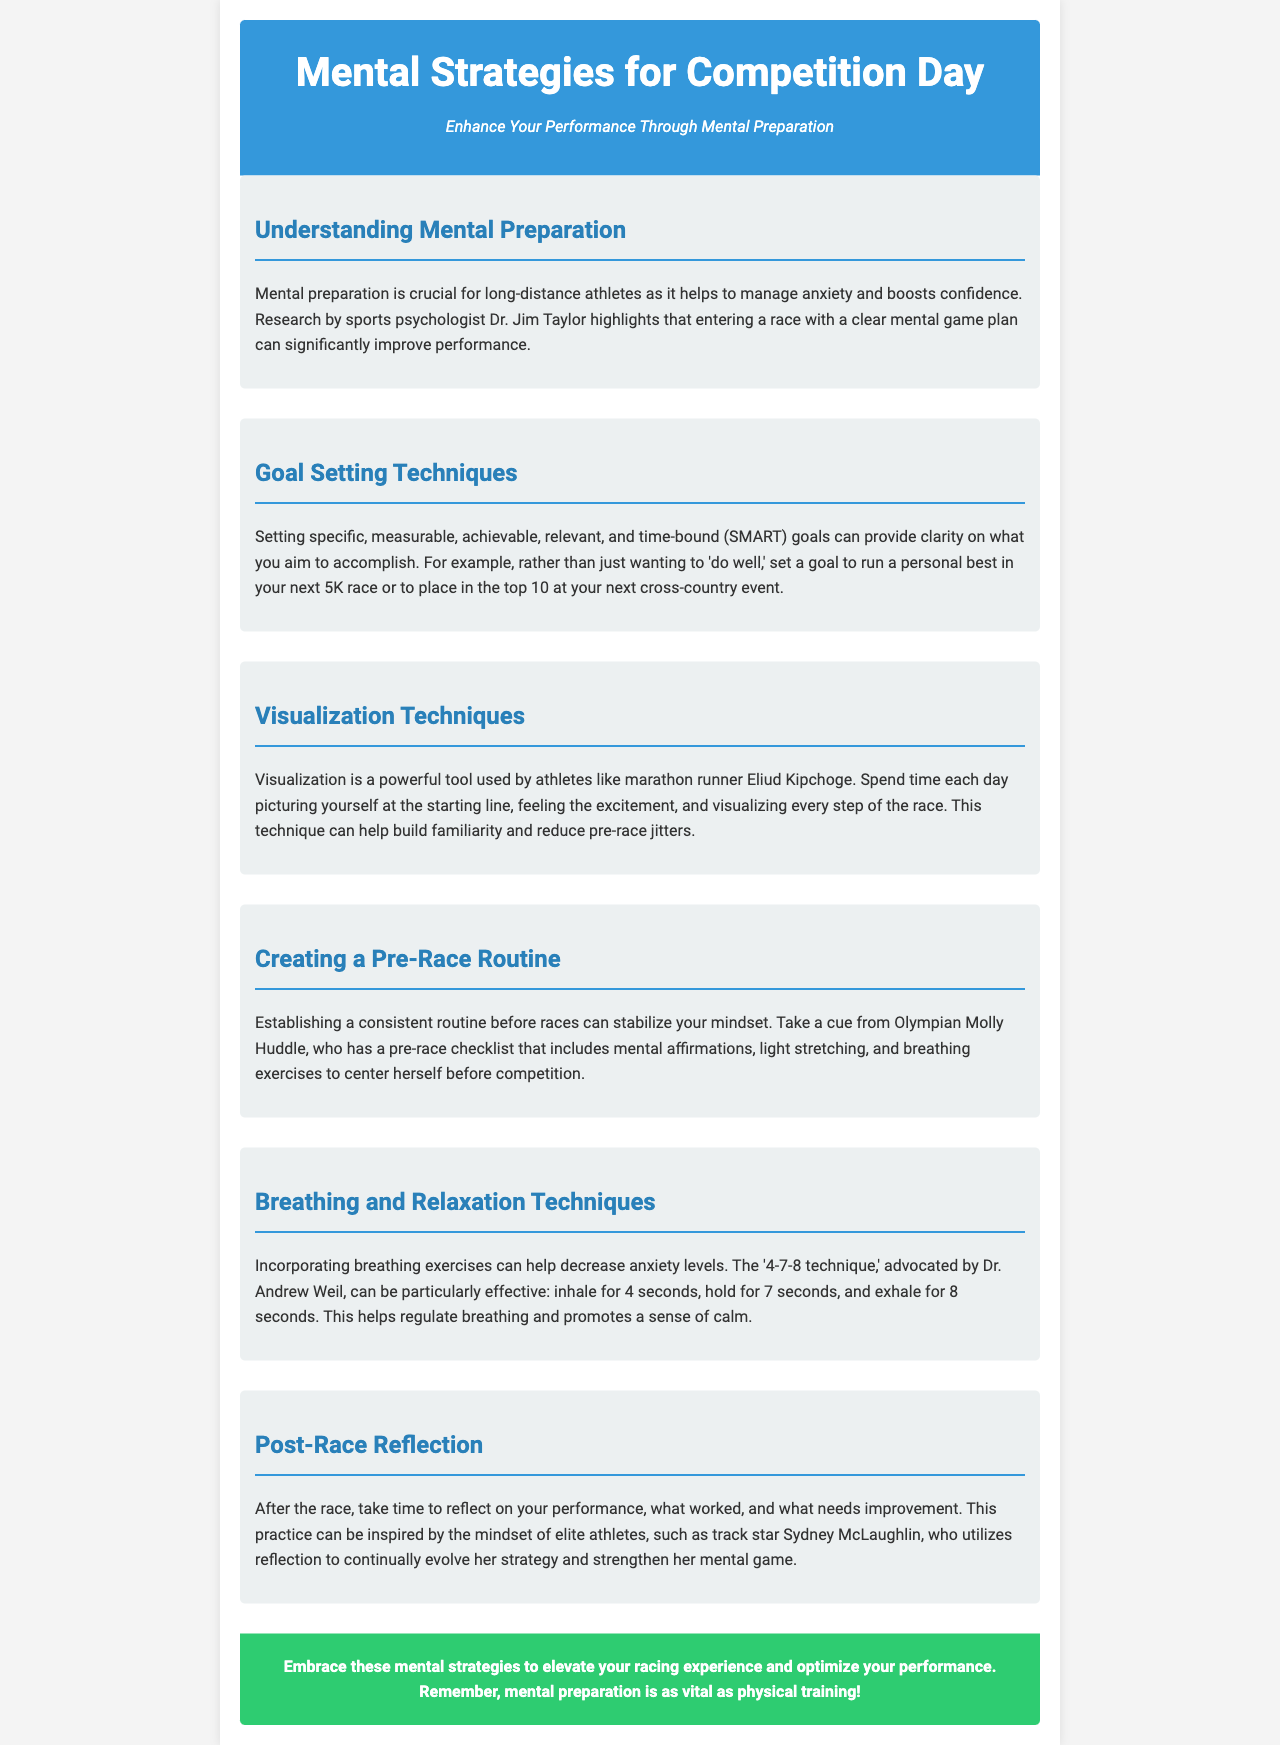What is the title of the newsletter? The title of the newsletter is explicitly stated at the beginning, focusing on mental strategies for competition day.
Answer: Mental Strategies for Competition Day Who conducted research emphasizing mental game plans? The document mentions a specific sports psychologist who conducted the research on mental preparation, highlighting their contributions.
Answer: Dr. Jim Taylor What technique is used by Eliud Kipchoge? The document identifies a mental imagery practice employed by this renowned marathon runner to enhance performance.
Answer: Visualization What should a pre-race routine include according to Molly Huddle? The newsletter provides a specific example of elements in a pre-race preparation checklist recommended by an Olympian for achieving mental readiness.
Answer: Mental affirmations What is the recommended breathing technique to decrease anxiety? The document refers to a specific breathing method linked to relaxation that is recognized by a notable doctor.
Answer: 4-7-8 technique How does Sydney McLaughlin approach post-race reflection? The document describes the practice of reflection that elite athletes like her utilize to continuously improve their performance.
Answer: Reflection What type of goals are suggested for athletes? The newsletter suggests a systematic way of setting objectives to give clarity and direction for competition.
Answer: SMART goals How does mental preparation compare to physical training? A concluding remark in the newsletter emphasizes the equal importance of both aspects in athletic performance.
Answer: Equally vital 